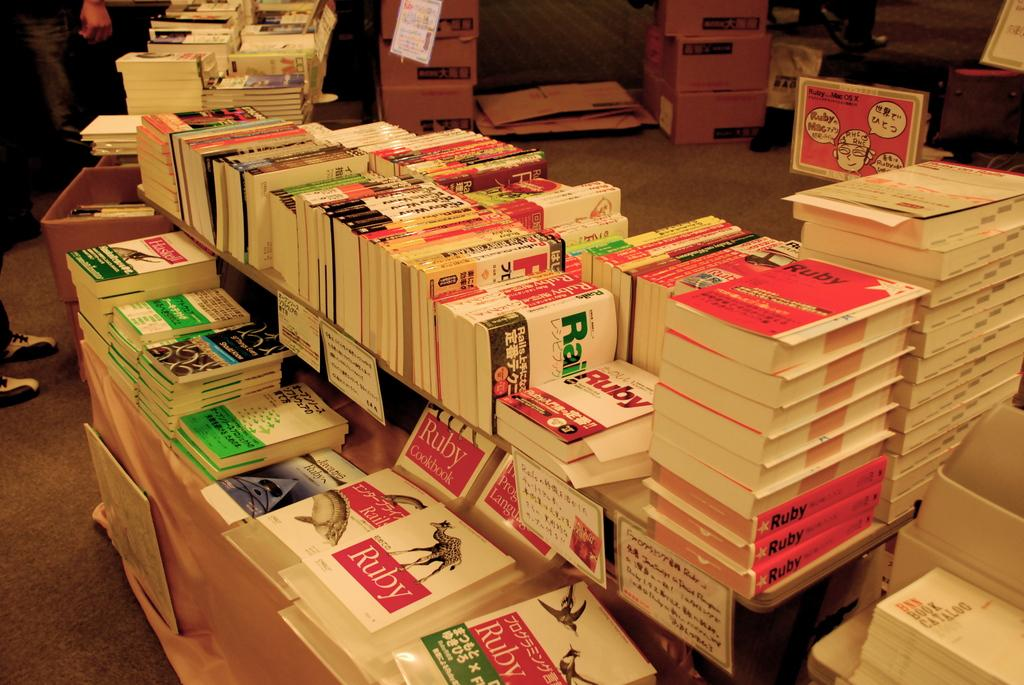<image>
Render a clear and concise summary of the photo. Several books are lined up on a sales table, including several by Ruby. 